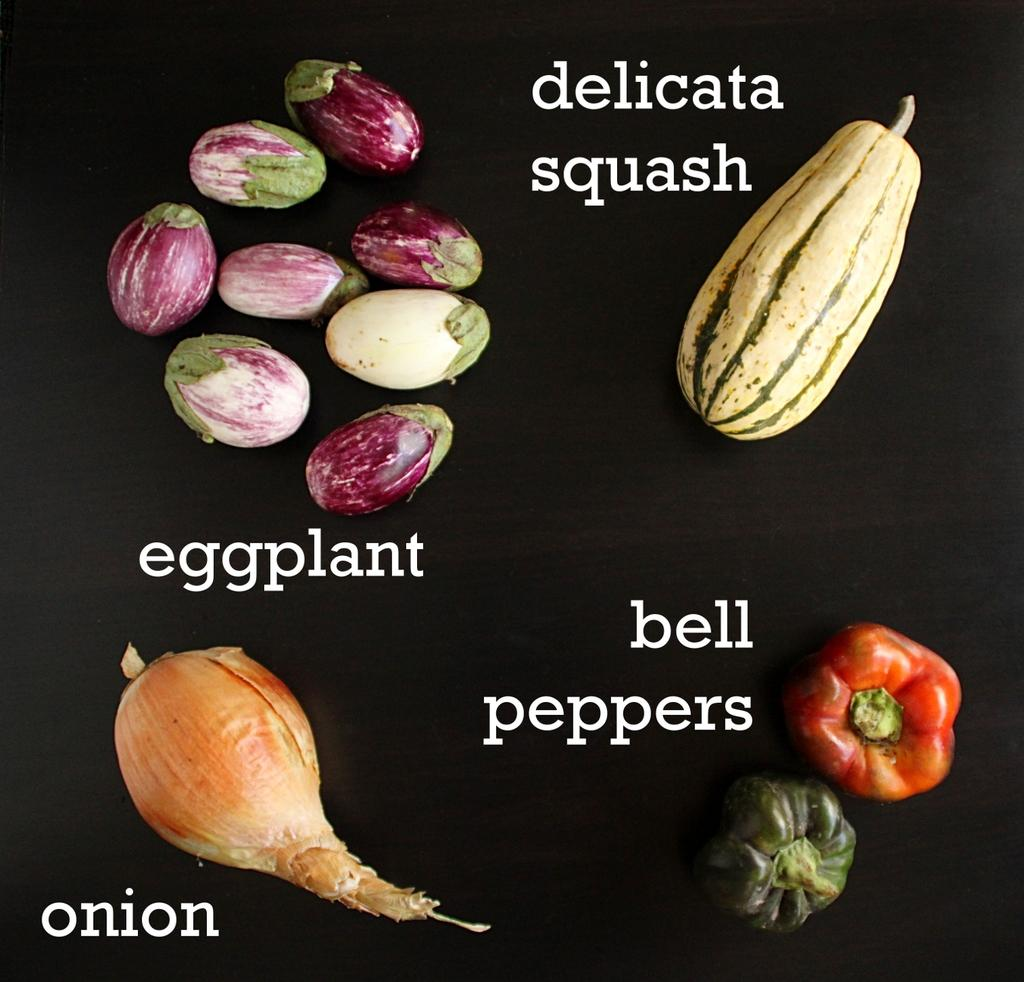What is depicted on the poster in the image? There is a poster of vegetables in the image. What else can be seen on the poster besides the image of vegetables? There is text on the poster. What is the color of the background in the image? The background of the image is dark. What type of fact can be found on the poster about the property of the vegetables? There is no information about the property of the vegetables on the poster, as it only features an image of vegetables and text. 